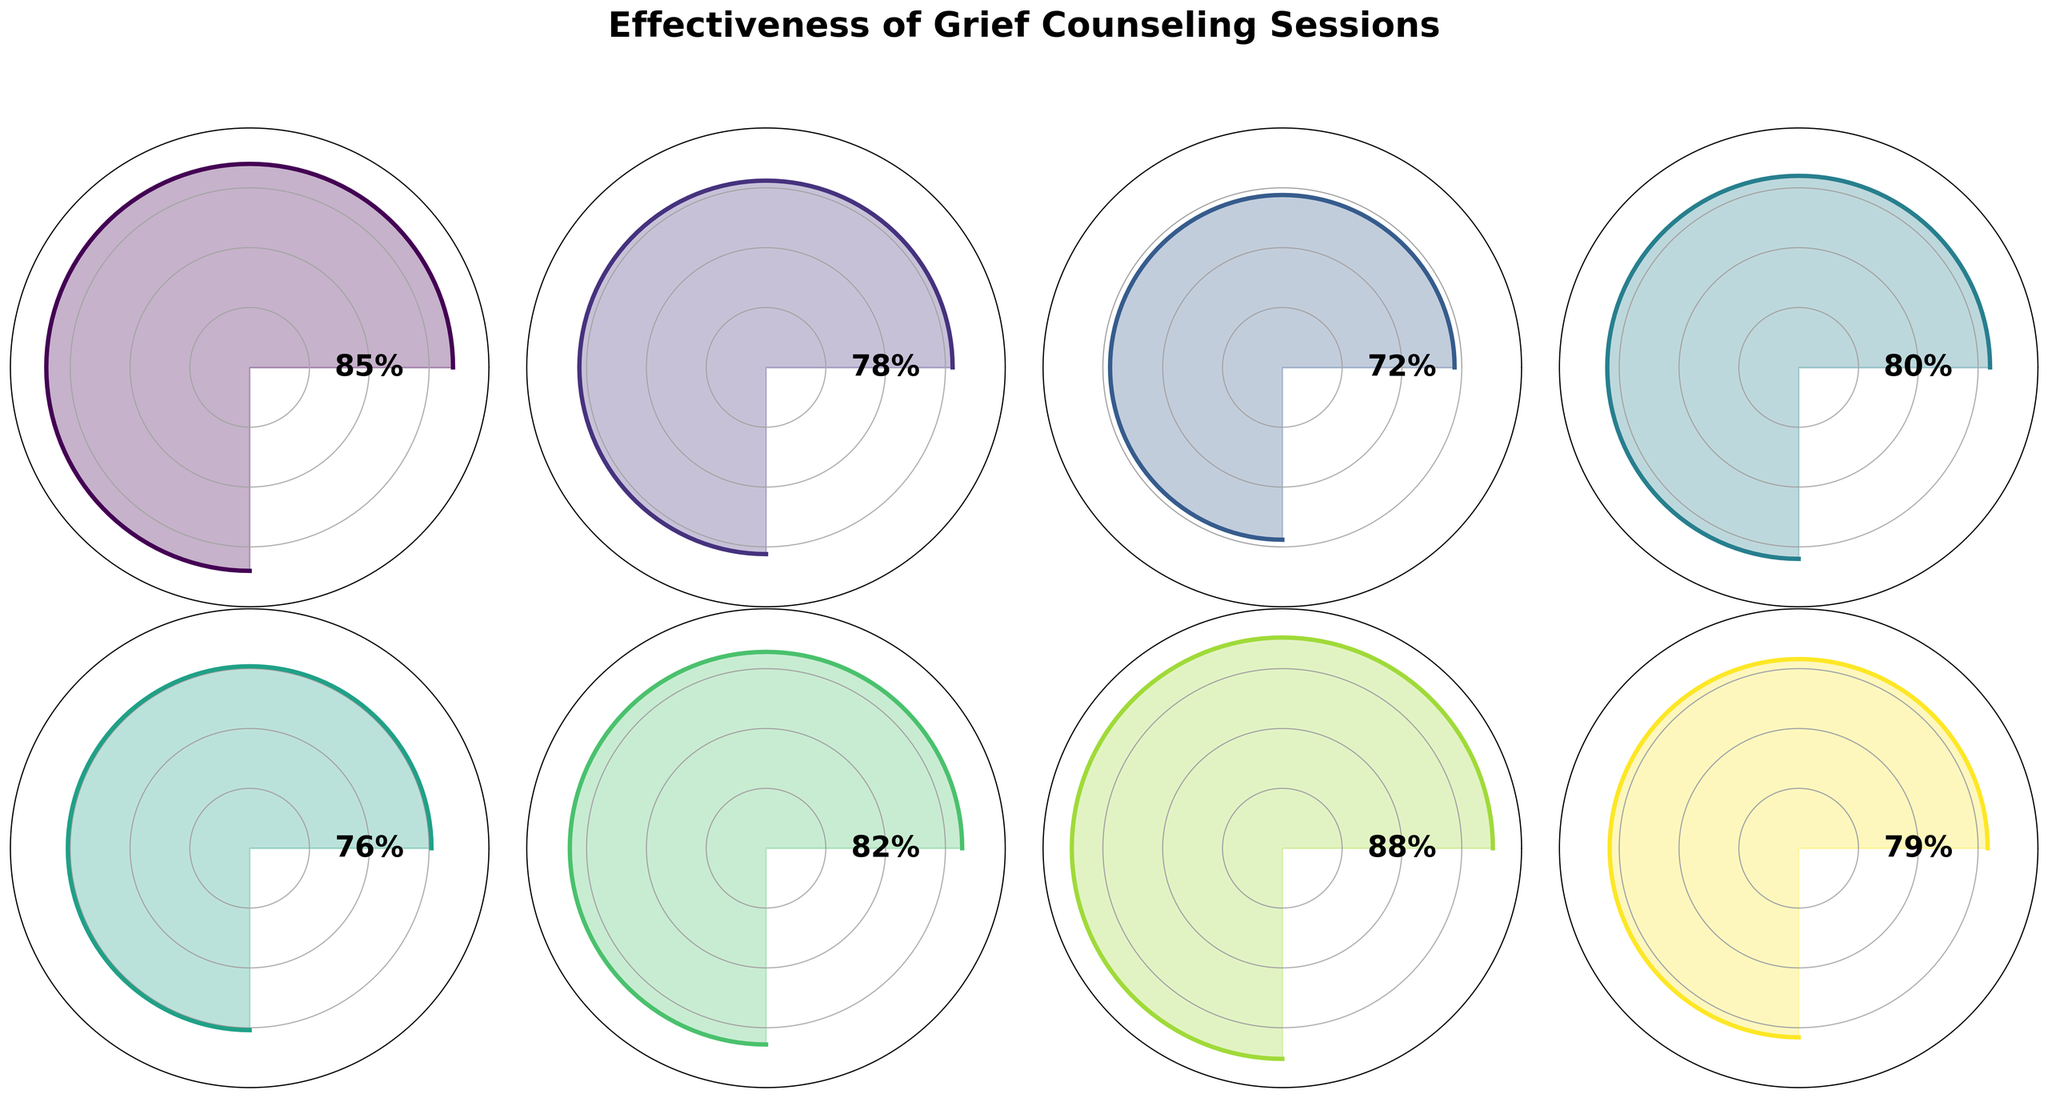Which type of counseling session has the highest effectiveness rating? The title of the gauge chart mentions effectiveness ratings, and by comparing the percentage values around the plot, you can see that "Family Counseling" has the highest rating at 88%.
Answer: Family Counseling What is the effectiveness rating for mindfulness meditation classes? Locate the "Mindfulness Meditation Classes" section in the gauge chart, and see that its effectiveness rating is 76%.
Answer: 76% What are the names and ratings of the top three most effective sessions? Compare all the sections in the gauge chart, list the top three highest ratings: "Family Counseling" (88%), "Individual Counseling" (85%), and "Peer Support Matching" (82%).
Answer: Family Counseling (88%), Individual Counseling (85%), Peer Support Matching (82%) How many sessions have an effectiveness rating of 80% or above? Identify the sections with ratings of 80% or higher: "Family Counseling" (88%), "Individual Counseling" (85%), "Peer Support Matching" (82%), and "Art Therapy Workshops" (80%).
Answer: 4 What is the average effectiveness rating for all counseling sessions? Sum the ratings: 85 + 78 + 72 + 80 + 76 + 82 + 88 + 79 = 640. Then, divide by the number of sessions: 640 / 8 = 80.
Answer: 80 Which session has the lowest effectiveness rating? Compare all sections and find that "Online Support Forums" has the lowest rating at 72%.
Answer: Online Support Forums How much higher is the effectiveness rating of individual counseling compared to group therapy sessions? Individual Counseling has a rating of 85%, and Group Therapy Sessions have 78%. Subtract to find the difference: 85 - 78 = 7.
Answer: 7 Do any sessions have the same effectiveness rating? Check all sections for identical ratings and find that no two sessions have the same rating.
Answer: No What is the total effectiveness rating for the peer support matching and art therapy workshops combined? Sum the ratings of "Peer Support Matching" (82%) and "Art Therapy Workshops" (80%): 82 + 80 = 162.
Answer: 162 Is the effectiveness rating of grief education seminars above or below average? The average effectiveness rating is 80%. The rating for "Grief Education Seminars" is 79%, which is below the average.
Answer: Below 